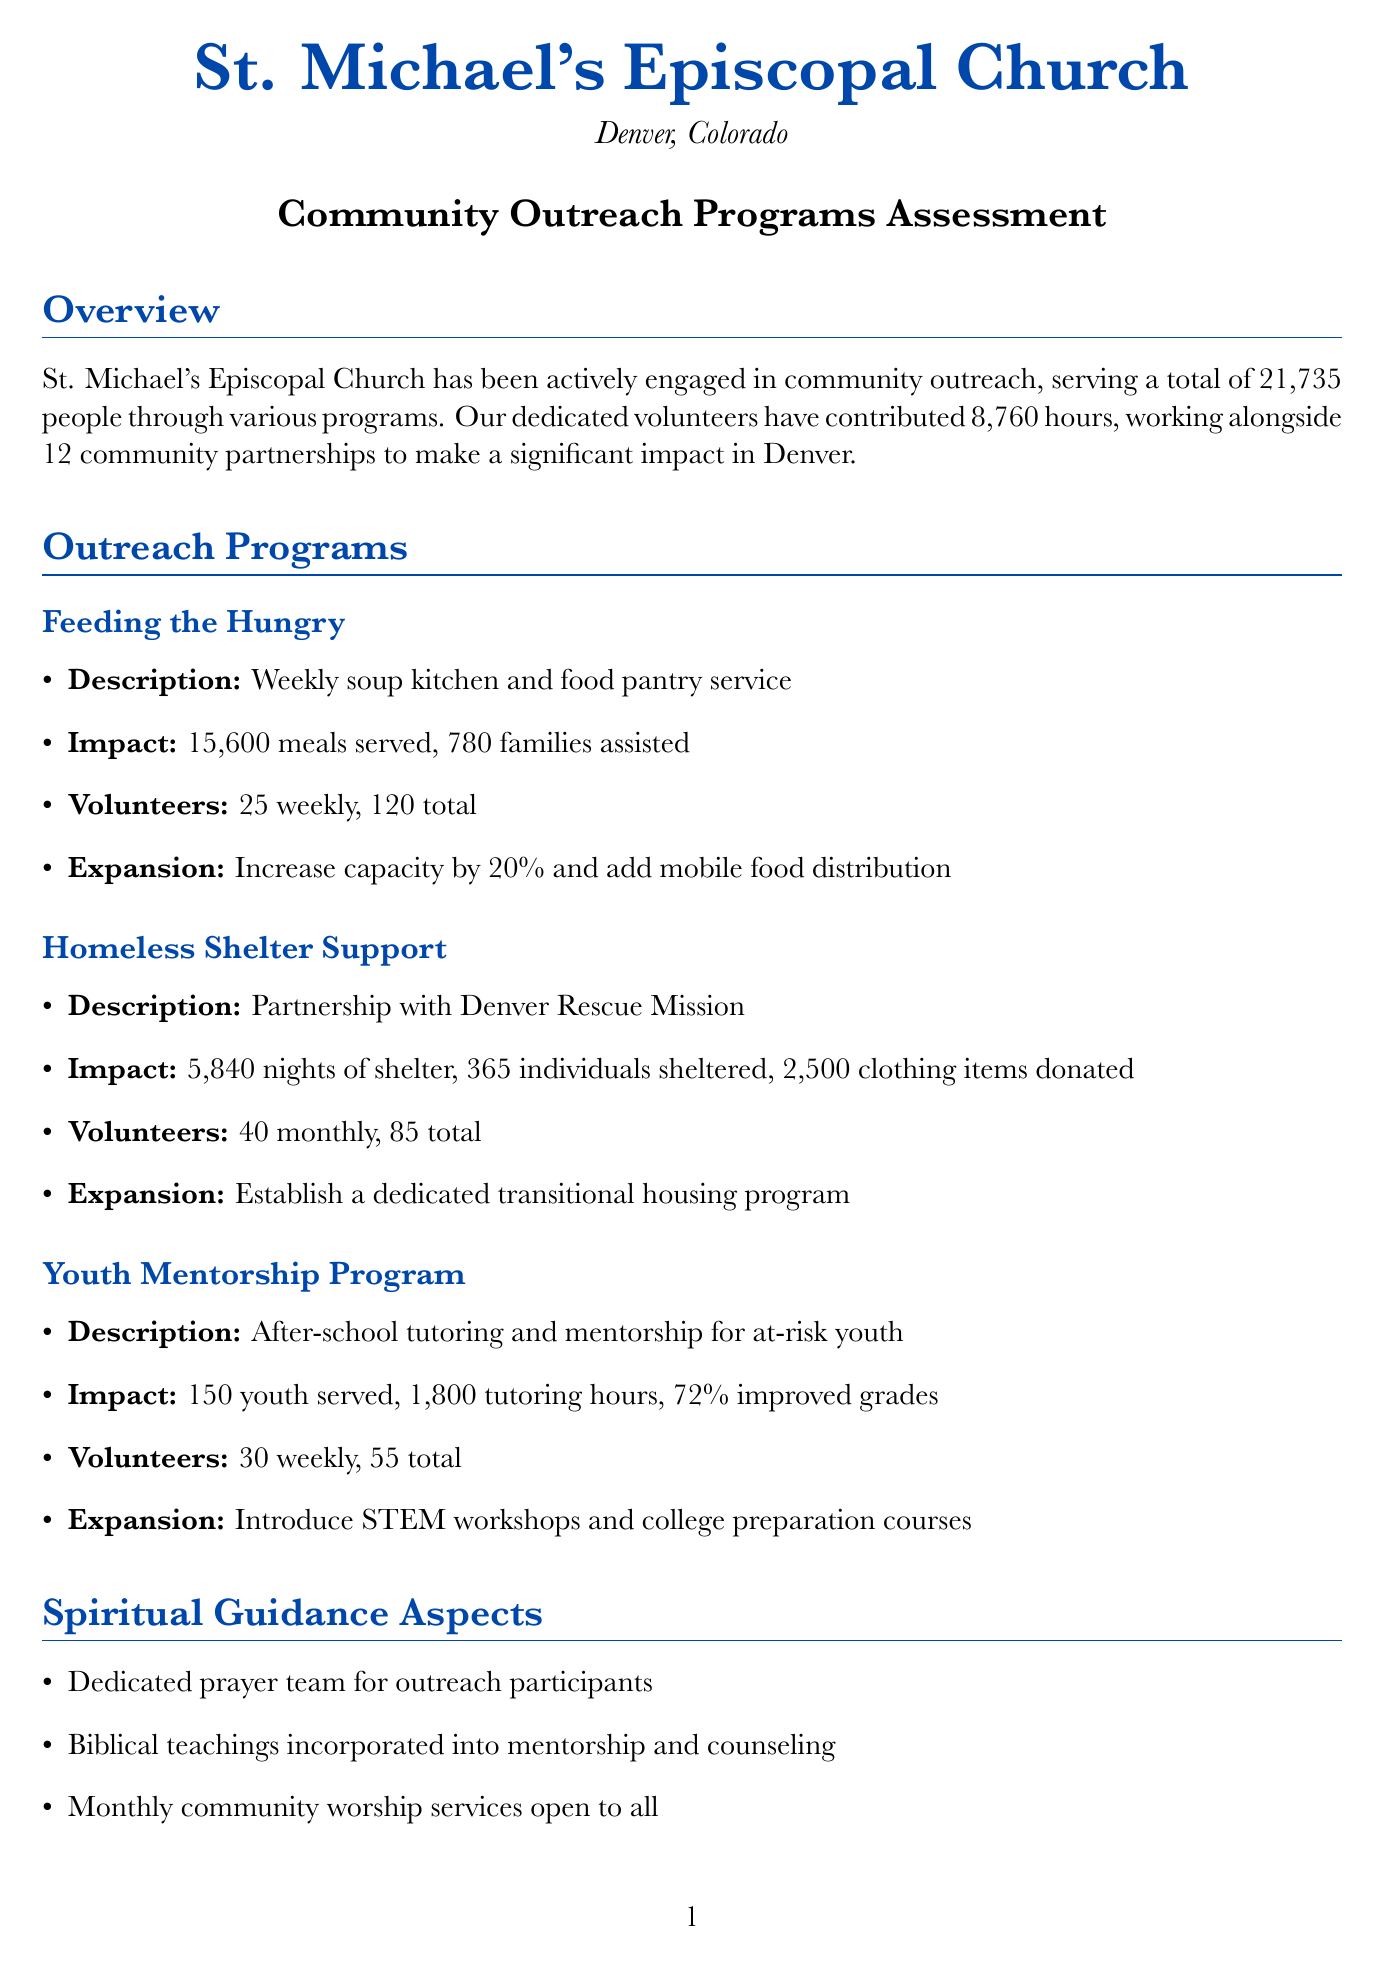What is the total number of people served by the church's outreach programs? The total number of people served is summarized in the overall impact section of the document.
Answer: 21,735 How many meals were served through the Feeding the Hungry program? The impact statistics for the Feeding the Hungry program specifies the number of meals served.
Answer: 15,600 What is the planned expansion for the Homeless Shelter Support program? The expansion plans for the Homeless Shelter Support program are outlined in the document.
Answer: Establish a dedicated transitional housing program How many total volunteer hours were contributed to all outreach programs? The overall impact section provides the total volunteer hours contributed by volunteers across all programs.
Answer: 8,760 What percentage of the church's annual giving is dedicated to outreach? The funding and resources section states the percentage of annual giving allocated to outreach.
Answer: 15% What specific areas does the future focus of the church include? The future focus section lists key areas the church aims to develop in its outreach efforts.
Answer: Environmental stewardship, mental health support, digital inclusion Who provided a testimonial about the Food Pantry service? The testimonials section identifies individuals who provided quotes about their experiences.
Answer: Sarah Johnson How many individuals were sheltered through the Homeless Shelter Support program? The impact statistics for the Homeless Shelter Support program includes the number of individuals sheltered.
Answer: 365 What is the annual budget for the church's outreach programs? The funding and resources section specifies the annual budget allocated for outreach efforts.
Answer: $250,000 